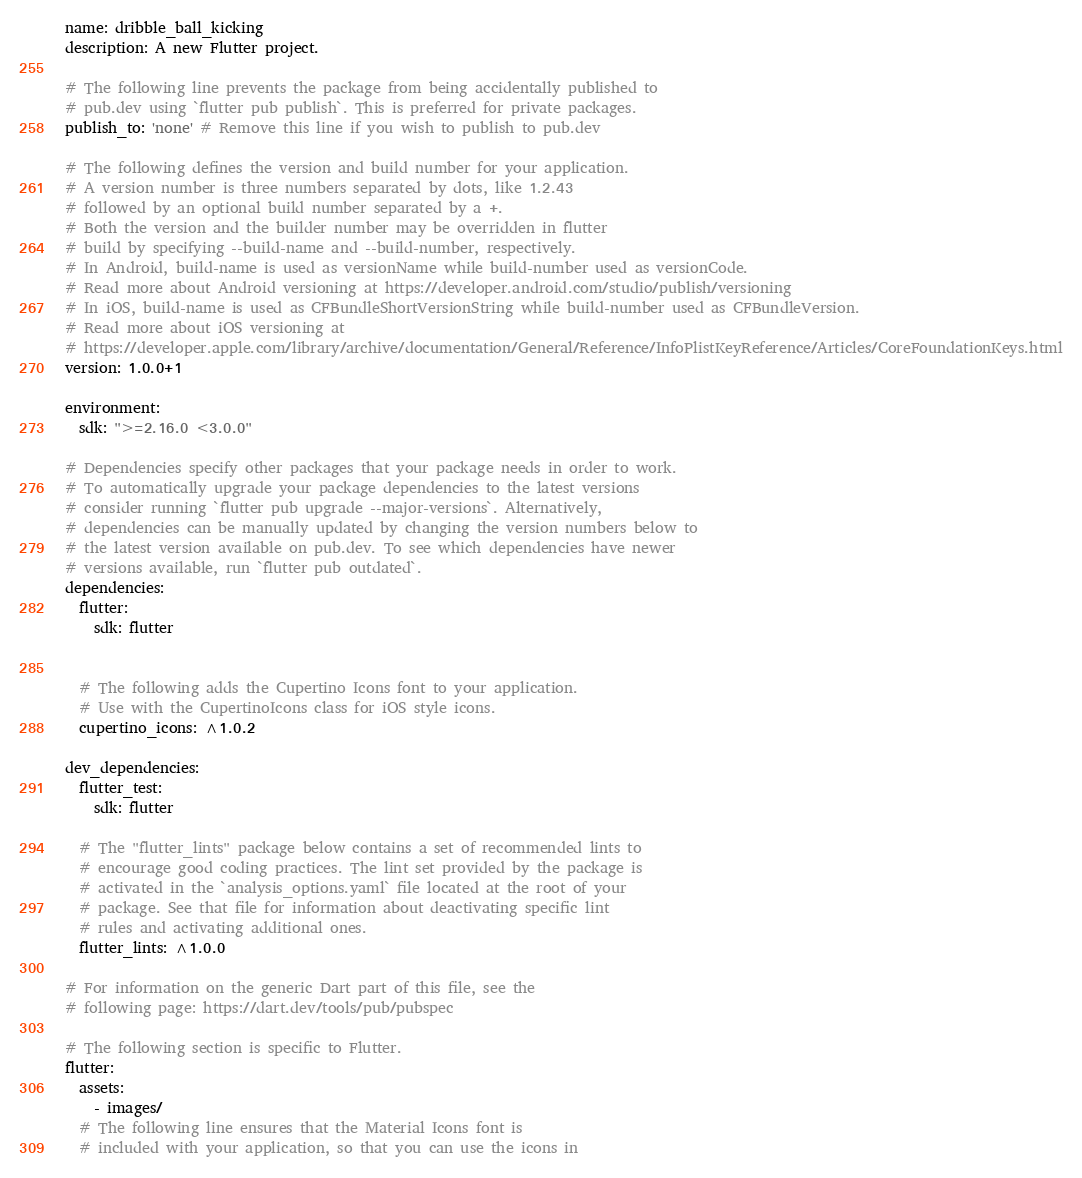<code> <loc_0><loc_0><loc_500><loc_500><_YAML_>name: dribble_ball_kicking
description: A new Flutter project.

# The following line prevents the package from being accidentally published to
# pub.dev using `flutter pub publish`. This is preferred for private packages.
publish_to: 'none' # Remove this line if you wish to publish to pub.dev

# The following defines the version and build number for your application.
# A version number is three numbers separated by dots, like 1.2.43
# followed by an optional build number separated by a +.
# Both the version and the builder number may be overridden in flutter
# build by specifying --build-name and --build-number, respectively.
# In Android, build-name is used as versionName while build-number used as versionCode.
# Read more about Android versioning at https://developer.android.com/studio/publish/versioning
# In iOS, build-name is used as CFBundleShortVersionString while build-number used as CFBundleVersion.
# Read more about iOS versioning at
# https://developer.apple.com/library/archive/documentation/General/Reference/InfoPlistKeyReference/Articles/CoreFoundationKeys.html
version: 1.0.0+1

environment:
  sdk: ">=2.16.0 <3.0.0"

# Dependencies specify other packages that your package needs in order to work.
# To automatically upgrade your package dependencies to the latest versions
# consider running `flutter pub upgrade --major-versions`. Alternatively,
# dependencies can be manually updated by changing the version numbers below to
# the latest version available on pub.dev. To see which dependencies have newer
# versions available, run `flutter pub outdated`.
dependencies:
  flutter:
    sdk: flutter


  # The following adds the Cupertino Icons font to your application.
  # Use with the CupertinoIcons class for iOS style icons.
  cupertino_icons: ^1.0.2

dev_dependencies:
  flutter_test:
    sdk: flutter

  # The "flutter_lints" package below contains a set of recommended lints to
  # encourage good coding practices. The lint set provided by the package is
  # activated in the `analysis_options.yaml` file located at the root of your
  # package. See that file for information about deactivating specific lint
  # rules and activating additional ones.
  flutter_lints: ^1.0.0

# For information on the generic Dart part of this file, see the
# following page: https://dart.dev/tools/pub/pubspec

# The following section is specific to Flutter.
flutter:
  assets:
    - images/
  # The following line ensures that the Material Icons font is
  # included with your application, so that you can use the icons in</code> 